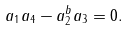Convert formula to latex. <formula><loc_0><loc_0><loc_500><loc_500>a _ { 1 } a _ { 4 } - a _ { 2 } ^ { b } a _ { 3 } = 0 .</formula> 